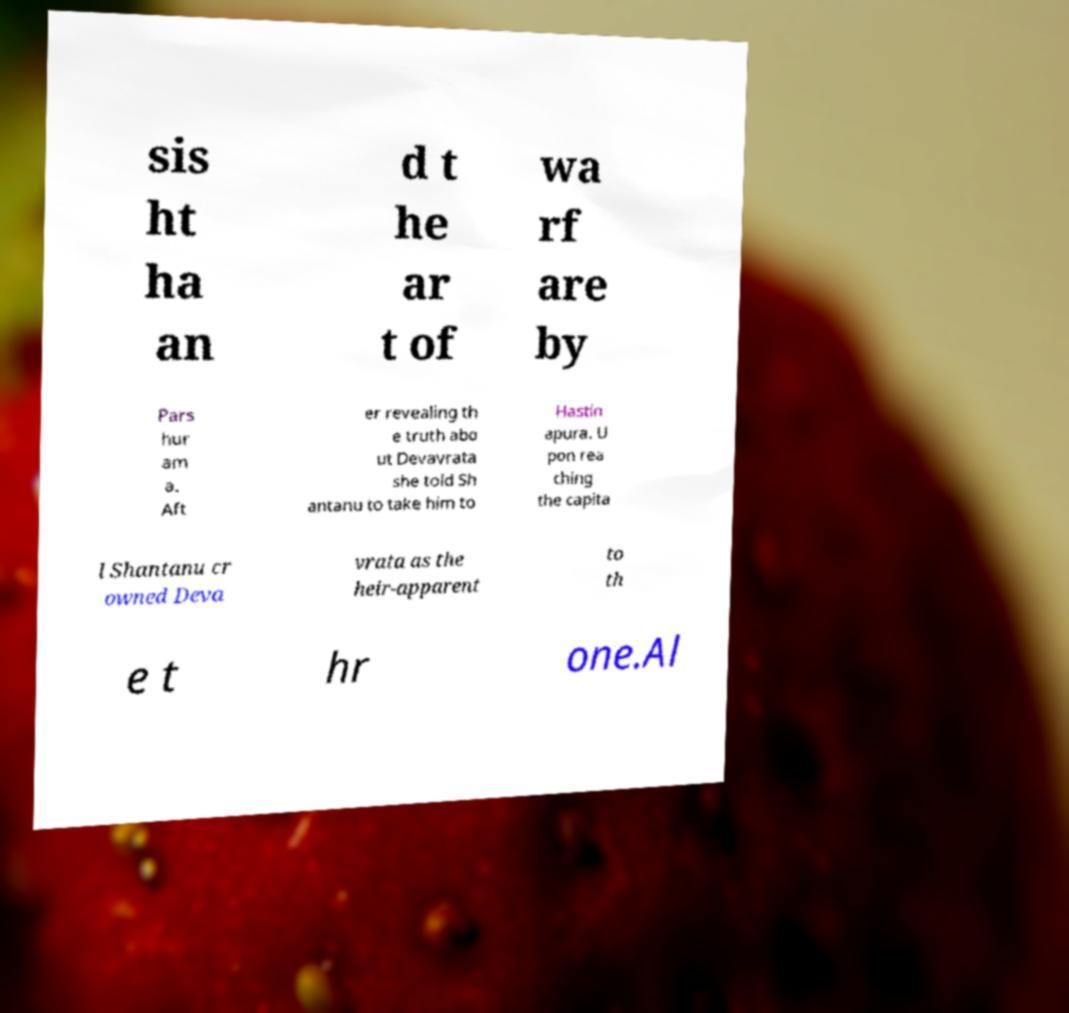What messages or text are displayed in this image? I need them in a readable, typed format. sis ht ha an d t he ar t of wa rf are by Pars hur am a. Aft er revealing th e truth abo ut Devavrata she told Sh antanu to take him to Hastin apura. U pon rea ching the capita l Shantanu cr owned Deva vrata as the heir-apparent to th e t hr one.Al 